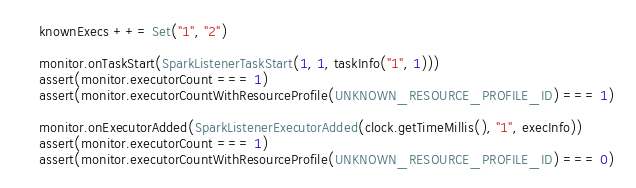<code> <loc_0><loc_0><loc_500><loc_500><_Scala_>    knownExecs ++= Set("1", "2")

    monitor.onTaskStart(SparkListenerTaskStart(1, 1, taskInfo("1", 1)))
    assert(monitor.executorCount === 1)
    assert(monitor.executorCountWithResourceProfile(UNKNOWN_RESOURCE_PROFILE_ID) === 1)

    monitor.onExecutorAdded(SparkListenerExecutorAdded(clock.getTimeMillis(), "1", execInfo))
    assert(monitor.executorCount === 1)
    assert(monitor.executorCountWithResourceProfile(UNKNOWN_RESOURCE_PROFILE_ID) === 0)</code> 